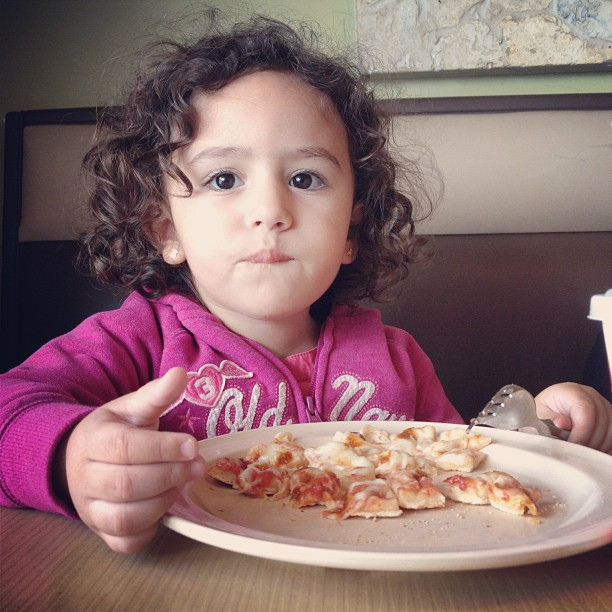<image>What does she have in her mouth? I don't know what she has in her mouth. It could be ravioli, lip, food or pizza. What facial expression does the girl have? It is ambiguous what facial expression the girl has. It can be any from confused, concentrated, straight, bored, or neutral. What does she have in her mouth? I don't know what she has in her mouth. It can be ravioli, lip, food or pizza. What facial expression does the girl have? I don't know what facial expression the girl has. It is not clear from the given information. 